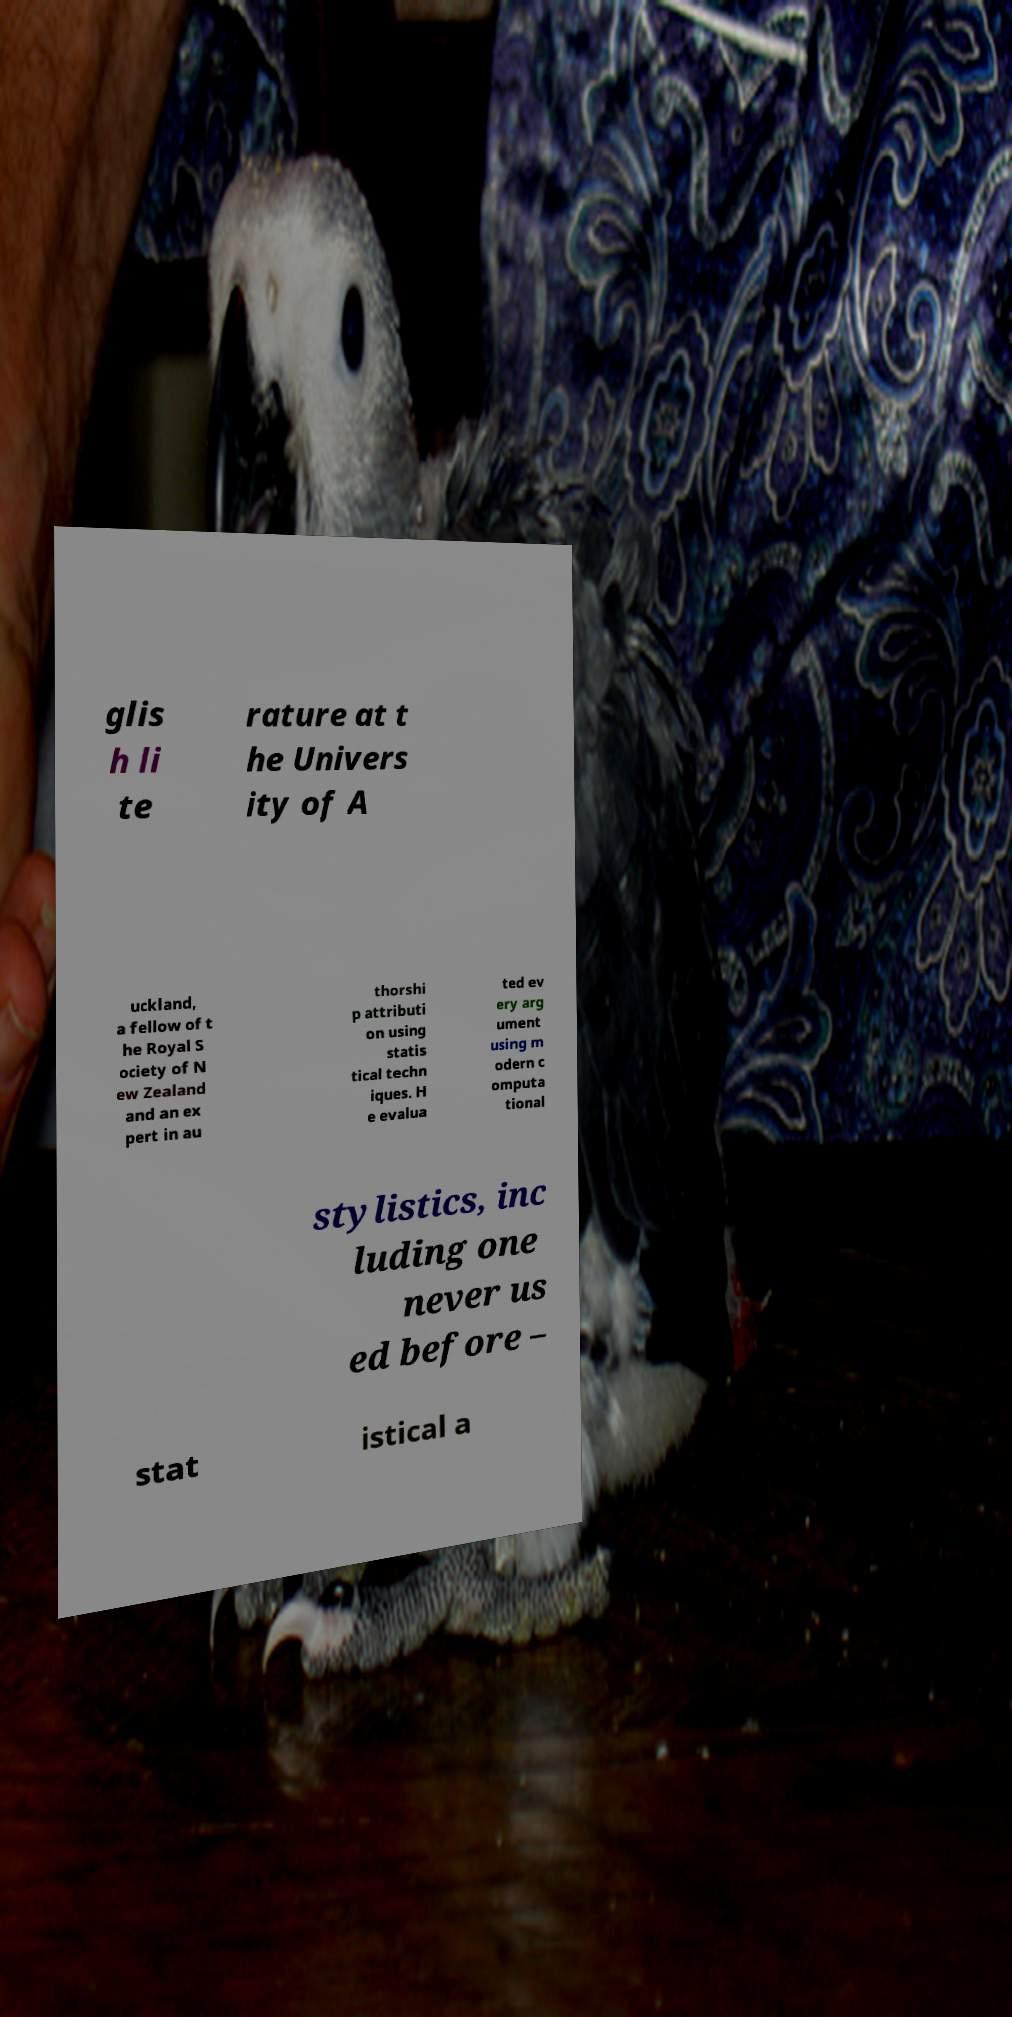Could you assist in decoding the text presented in this image and type it out clearly? glis h li te rature at t he Univers ity of A uckland, a fellow of t he Royal S ociety of N ew Zealand and an ex pert in au thorshi p attributi on using statis tical techn iques. H e evalua ted ev ery arg ument using m odern c omputa tional stylistics, inc luding one never us ed before – stat istical a 